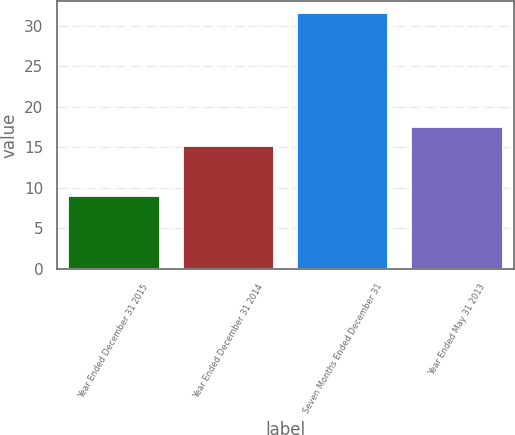Convert chart. <chart><loc_0><loc_0><loc_500><loc_500><bar_chart><fcel>Year Ended December 31 2015<fcel>Year Ended December 31 2014<fcel>Seven Months Ended December 31<fcel>Year Ended May 31 2013<nl><fcel>9<fcel>15.2<fcel>31.5<fcel>17.45<nl></chart> 